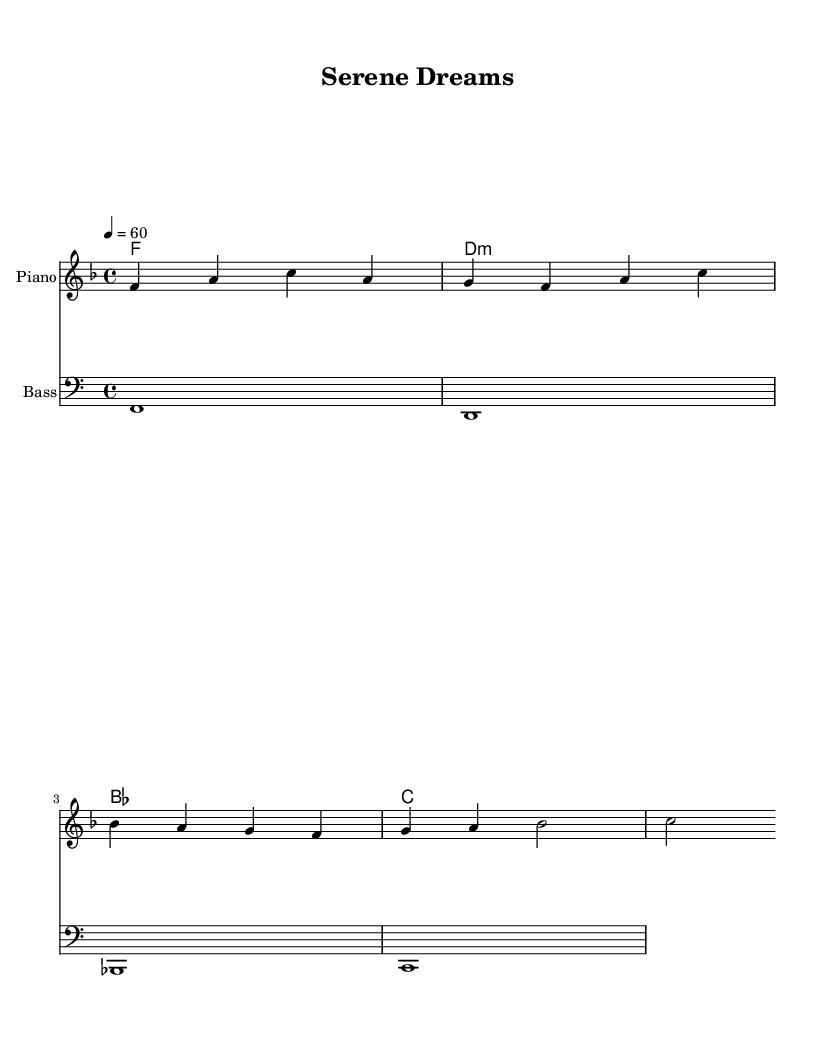What is the key signature of this music? The key signature is F major, indicated by one flat (B flat) on the staff.
Answer: F major What is the time signature of this music? The time signature is 4/4, which means there are four beats in each measure.
Answer: 4/4 What is the tempo marking of this piece? The tempo marking is 60 beats per minute, as indicated at the start of the score.
Answer: 60 How many measures are in the melody section? The melody section consists of four measures, as clearly separated by bar lines.
Answer: 4 What is the name of the instrument played for the melody? The instrument indicated for the melody is a piano, as shown in the staff description.
Answer: Piano What type of music is “Serene Dreams” considered to be? The piece is characterized as soothing K-Pop lo-fi beats for relaxation and focus, reflecting its calming nature.
Answer: Soothing K-Pop lo-fi What is the first note in the melody? The first note in the melody is F, which is located at the beginning of the melody line.
Answer: F 